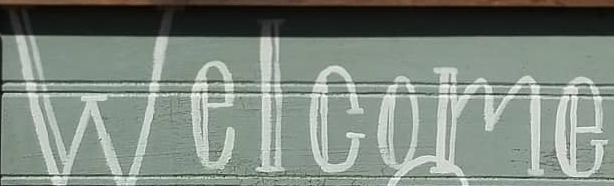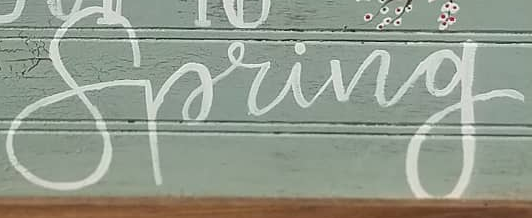Identify the words shown in these images in order, separated by a semicolon. Welcome; Spring 